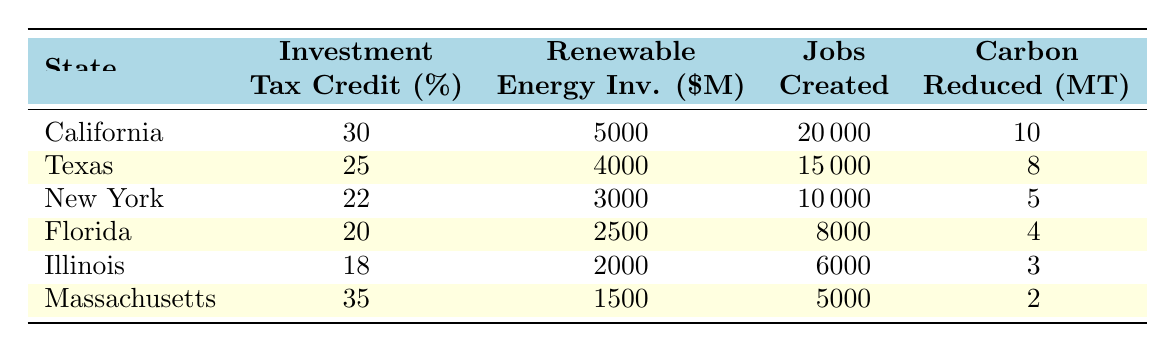What is the investment tax credit percentage for California? The investment tax credit for California is listed directly in the table under the "Investment Tax Credit (%)" column corresponding to California.
Answer: 30 How much renewable energy investment (in million $) did Texas achieve? The renewable energy investment for Texas is found in the "Renewable Energy Inv. ($M)" column next to Texas in the table.
Answer: 4000 Which state created more than 15,000 jobs through renewable energy investments? By examining the "Jobs Created" column in the table, Texas created 15,000 jobs, while California created 20,000 jobs. California is the only state that created more than 15,000 jobs.
Answer: Yes What is the total renewable energy investment across all states listed? To find the total, sum the values from the "Renewable Energy Inv. ($M)" column: 5000 + 4000 + 3000 + 2500 + 2000 + 1500 = 18,000.
Answer: 18000 Is the carbon emissions reduced from Massachusetts greater than 5 million tons? The reduced carbon emissions for Massachusetts is stated as 2 million tons, which is lower than 5 million tons.
Answer: No What is the average investment tax credit percentage across all states? Calculate the average by summing the tax credits: (30 + 25 + 22 + 20 + 18 + 35) = 150 and divide by the number of states (6): 150 / 6 = 25.
Answer: 25 Which state has the highest carbon emissions reduction, and what is the amount? Look in the "Carbon Reduced (MT)" column to see that California has the highest at 10 million tons.
Answer: California, 10 How many jobs were created in states with an investment tax credit percentage higher than 20%? Identify the states with tax credits greater than 20%, which are California (20,000 jobs), Texas (15,000 jobs), and Massachusetts (5,000 jobs). Sum these: 20,000 + 15,000 + 5,000 = 40,000 jobs.
Answer: 40000 Which state had the least amount of renewable energy investment, and what was the amount? By checking the "Renewable Energy Inv. ($M)" data, Massachusetts had the least investment at 1500 million dollars.
Answer: Massachusetts, 1500 